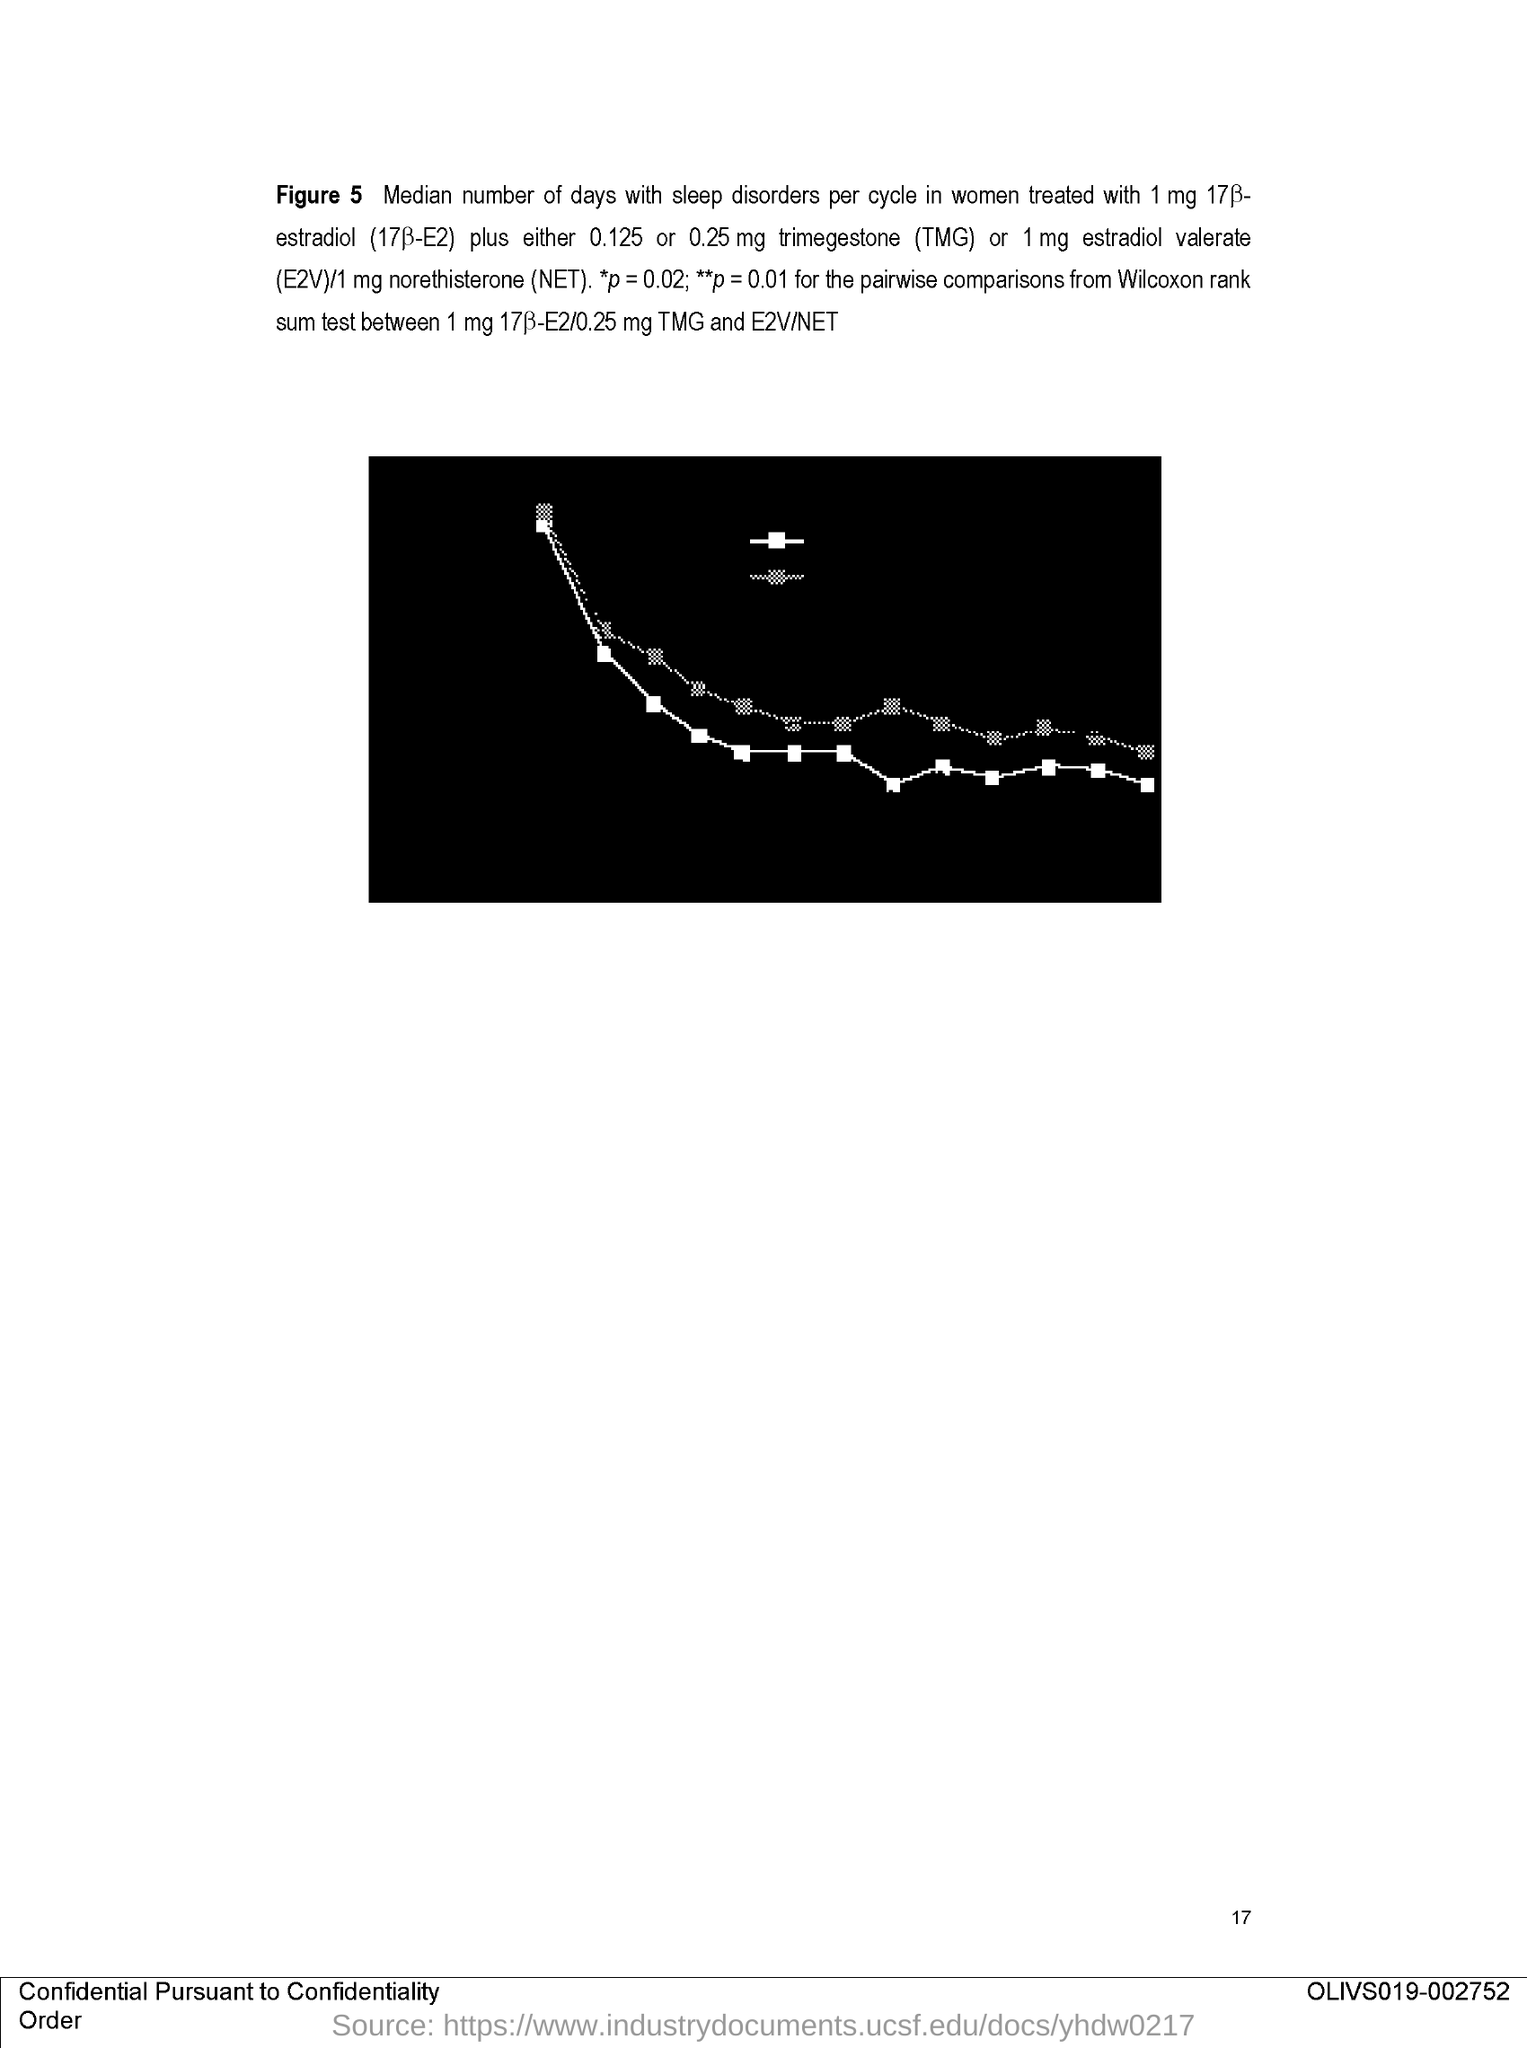What is the Page Number?
Make the answer very short. 17. 